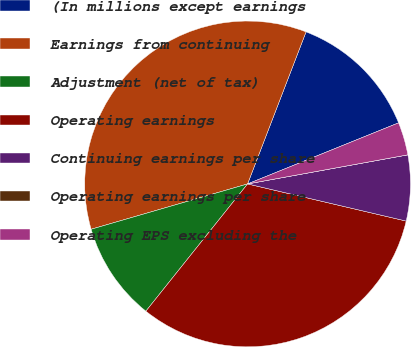Convert chart. <chart><loc_0><loc_0><loc_500><loc_500><pie_chart><fcel>(In millions except earnings<fcel>Earnings from continuing<fcel>Adjustment (net of tax)<fcel>Operating earnings<fcel>Continuing earnings per share<fcel>Operating earnings per share<fcel>Operating EPS excluding the<nl><fcel>13.04%<fcel>35.33%<fcel>9.78%<fcel>32.07%<fcel>6.52%<fcel>0.0%<fcel>3.26%<nl></chart> 